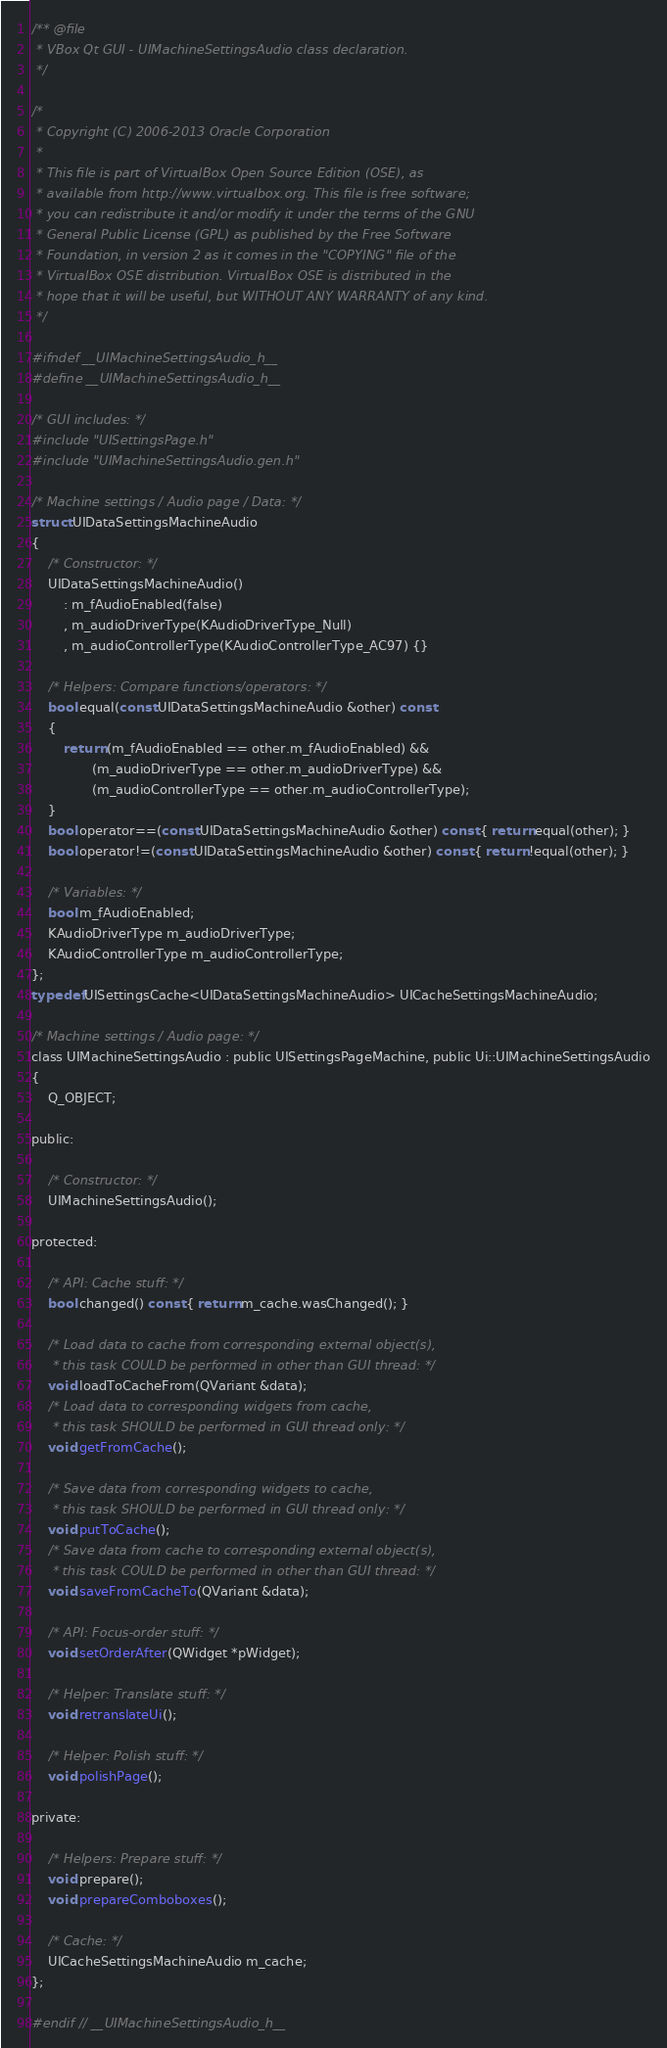Convert code to text. <code><loc_0><loc_0><loc_500><loc_500><_C_>/** @file
 * VBox Qt GUI - UIMachineSettingsAudio class declaration.
 */

/*
 * Copyright (C) 2006-2013 Oracle Corporation
 *
 * This file is part of VirtualBox Open Source Edition (OSE), as
 * available from http://www.virtualbox.org. This file is free software;
 * you can redistribute it and/or modify it under the terms of the GNU
 * General Public License (GPL) as published by the Free Software
 * Foundation, in version 2 as it comes in the "COPYING" file of the
 * VirtualBox OSE distribution. VirtualBox OSE is distributed in the
 * hope that it will be useful, but WITHOUT ANY WARRANTY of any kind.
 */

#ifndef __UIMachineSettingsAudio_h__
#define __UIMachineSettingsAudio_h__

/* GUI includes: */
#include "UISettingsPage.h"
#include "UIMachineSettingsAudio.gen.h"

/* Machine settings / Audio page / Data: */
struct UIDataSettingsMachineAudio
{
    /* Constructor: */
    UIDataSettingsMachineAudio()
        : m_fAudioEnabled(false)
        , m_audioDriverType(KAudioDriverType_Null)
        , m_audioControllerType(KAudioControllerType_AC97) {}

    /* Helpers: Compare functions/operators: */
    bool equal(const UIDataSettingsMachineAudio &other) const
    {
        return (m_fAudioEnabled == other.m_fAudioEnabled) &&
               (m_audioDriverType == other.m_audioDriverType) &&
               (m_audioControllerType == other.m_audioControllerType);
    }
    bool operator==(const UIDataSettingsMachineAudio &other) const { return equal(other); }
    bool operator!=(const UIDataSettingsMachineAudio &other) const { return !equal(other); }

    /* Variables: */
    bool m_fAudioEnabled;
    KAudioDriverType m_audioDriverType;
    KAudioControllerType m_audioControllerType;
};
typedef UISettingsCache<UIDataSettingsMachineAudio> UICacheSettingsMachineAudio;

/* Machine settings / Audio page: */
class UIMachineSettingsAudio : public UISettingsPageMachine, public Ui::UIMachineSettingsAudio
{
    Q_OBJECT;

public:

    /* Constructor: */
    UIMachineSettingsAudio();

protected:

    /* API: Cache stuff: */
    bool changed() const { return m_cache.wasChanged(); }

    /* Load data to cache from corresponding external object(s),
     * this task COULD be performed in other than GUI thread: */
    void loadToCacheFrom(QVariant &data);
    /* Load data to corresponding widgets from cache,
     * this task SHOULD be performed in GUI thread only: */
    void getFromCache();

    /* Save data from corresponding widgets to cache,
     * this task SHOULD be performed in GUI thread only: */
    void putToCache();
    /* Save data from cache to corresponding external object(s),
     * this task COULD be performed in other than GUI thread: */
    void saveFromCacheTo(QVariant &data);

    /* API: Focus-order stuff: */
    void setOrderAfter(QWidget *pWidget);

    /* Helper: Translate stuff: */
    void retranslateUi();

    /* Helper: Polish stuff: */
    void polishPage();

private:

    /* Helpers: Prepare stuff: */
    void prepare();
    void prepareComboboxes();

    /* Cache: */
    UICacheSettingsMachineAudio m_cache;
};

#endif // __UIMachineSettingsAudio_h__

</code> 